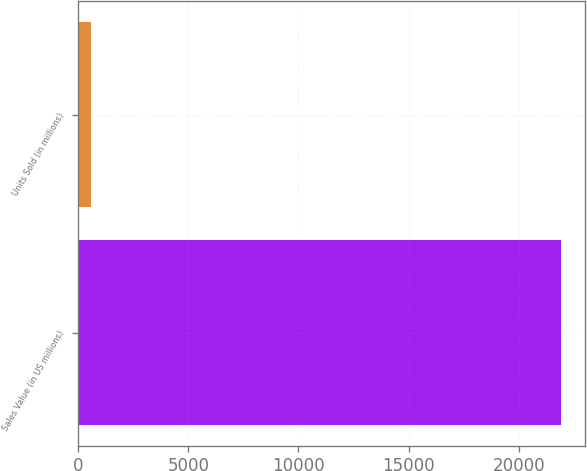Convert chart. <chart><loc_0><loc_0><loc_500><loc_500><bar_chart><fcel>Sales Value (in US millions)<fcel>Units Sold (in millions)<nl><fcel>21915<fcel>583.6<nl></chart> 